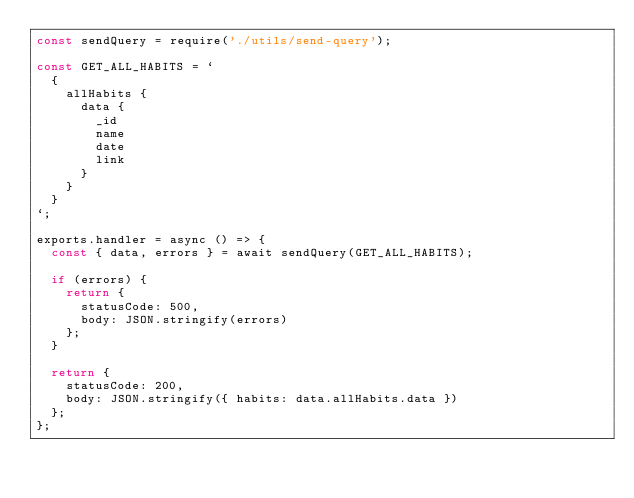Convert code to text. <code><loc_0><loc_0><loc_500><loc_500><_JavaScript_>const sendQuery = require('./utils/send-query');

const GET_ALL_HABITS = `
  {
    allHabits {
      data {
        _id
        name
        date
        link
      }
    }
  }
`;

exports.handler = async () => {
  const { data, errors } = await sendQuery(GET_ALL_HABITS);

  if (errors) {
    return {
      statusCode: 500,
      body: JSON.stringify(errors)
    };
  }

  return {
    statusCode: 200,
    body: JSON.stringify({ habits: data.allHabits.data })
  };
};
</code> 